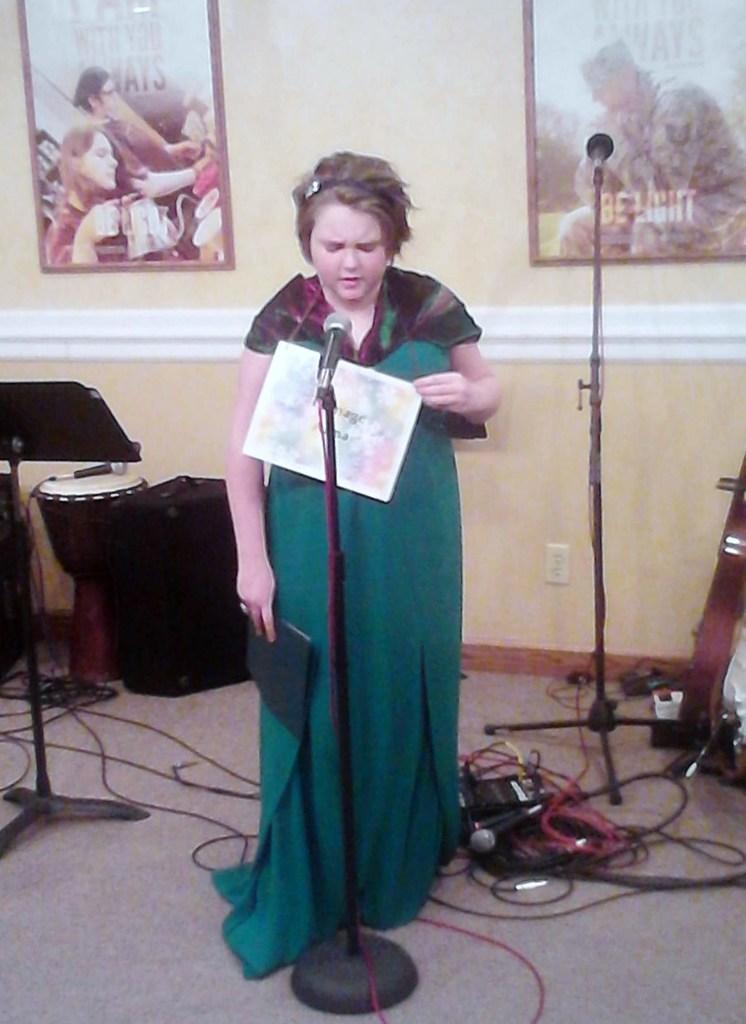Can you describe this image briefly? In the picture I can see a woman standing on the floor and looks like she is singing on a microphone. I can see a guitar, microphone and other musical instruments are kept on the floor. In the background, I can see the photo frames on the wall. 